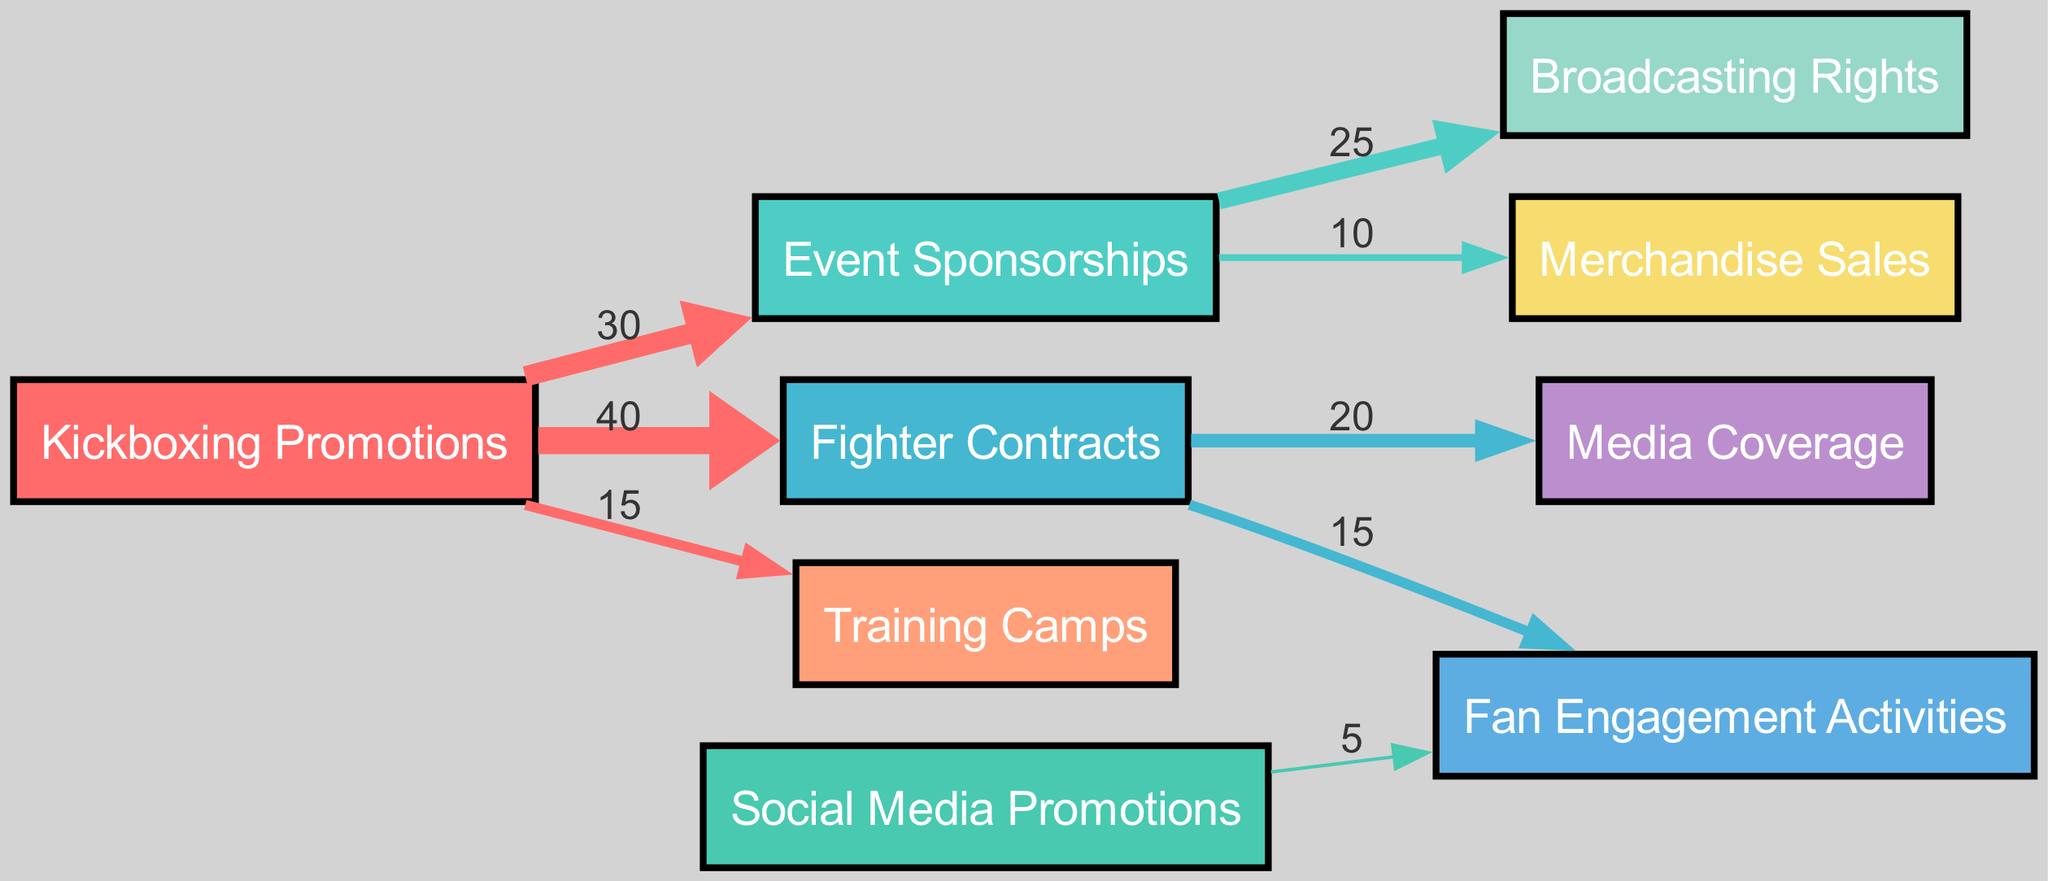What is the total funding allocated from Kickboxing Promotions to Fighter Contracts? From the diagram, Kickboxing Promotions allocates 40 to Fighter Contracts.
Answer: 40 How many nodes are present in the diagram? By counting the nodes listed, there are 9 distinct entities depicted in the diagram.
Answer: 9 What is the value associated with Event Sponsorships to Broadcasting Rights? The diagram indicates that Event Sponsorships allocates a value of 25 to Broadcasting Rights.
Answer: 25 Which node receives the least funding from Kickboxing Promotions? By evaluating the allocations from Kickboxing Promotions, Training Camps receives the least funding with a value of 15.
Answer: Training Camps What is the total funding that flows into Fan Engagement Activities? To find the total, we add the values from Fighter Contracts (15) and Social Media Promotions (5), resulting in a total of 20 going into Fan Engagement Activities.
Answer: 20 What percentage of the total funding from Kickboxing Promotions is allocated to Event Sponsorships? Kickboxing Promotions allocates a total of 85 (30 + 40 + 15). Event Sponsorships receives 30, which is 30/85 or about 35.3% of the total funding.
Answer: 35.3% Which entities receive funds directly from Fighter Contracts? Fighter Contracts directs funds to Media Coverage (20) and Fan Engagement Activities (15), establishing two direct recipients.
Answer: Media Coverage and Fan Engagement Activities How does the funding flow from Event Sponsorships to Merchandise Sales? Event Sponsorships allocates 10 to Merchandise Sales, indicating a direct flow from Event Sponsorships to this node.
Answer: 10 What role does Social Media Promotions have in supporting Fan Engagement Activities? Social Media Promotions contributes directly to Fan Engagement Activities, allocating 5 to enhance fan interaction initiatives.
Answer: 5 